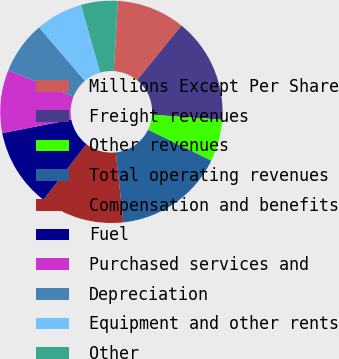Convert chart. <chart><loc_0><loc_0><loc_500><loc_500><pie_chart><fcel>Millions Except Per Share<fcel>Freight revenues<fcel>Other revenues<fcel>Total operating revenues<fcel>Compensation and benefits<fcel>Fuel<fcel>Purchased services and<fcel>Depreciation<fcel>Equipment and other rents<fcel>Other<nl><fcel>9.92%<fcel>15.27%<fcel>6.11%<fcel>16.03%<fcel>12.21%<fcel>11.45%<fcel>9.16%<fcel>7.63%<fcel>6.87%<fcel>5.34%<nl></chart> 